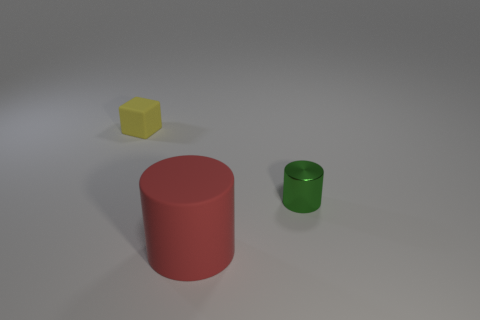Add 2 small rubber things. How many objects exist? 5 Subtract all blocks. How many objects are left? 2 Subtract all large yellow matte cylinders. Subtract all shiny cylinders. How many objects are left? 2 Add 2 big things. How many big things are left? 3 Add 1 red things. How many red things exist? 2 Subtract 0 brown cubes. How many objects are left? 3 